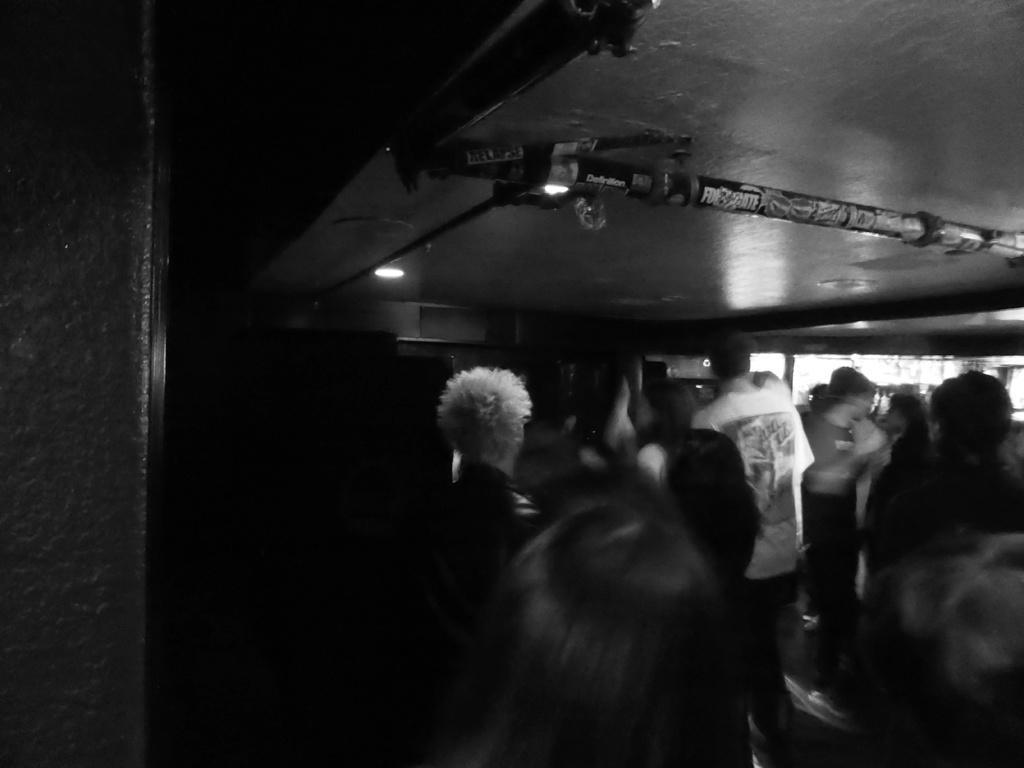Could you give a brief overview of what you see in this image? As we can see in the image there are group of people here and there and a wall. The image is little dark. 